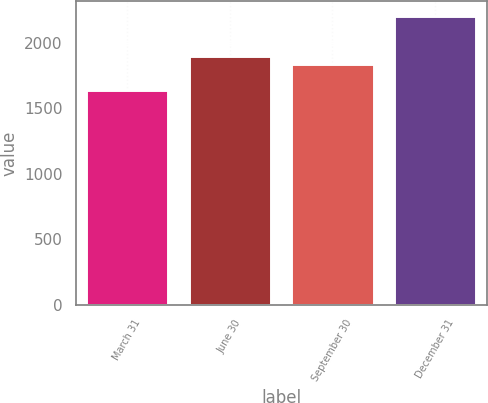Convert chart to OTSL. <chart><loc_0><loc_0><loc_500><loc_500><bar_chart><fcel>March 31<fcel>June 30<fcel>September 30<fcel>December 31<nl><fcel>1637.5<fcel>1898.06<fcel>1841.1<fcel>2207.1<nl></chart> 